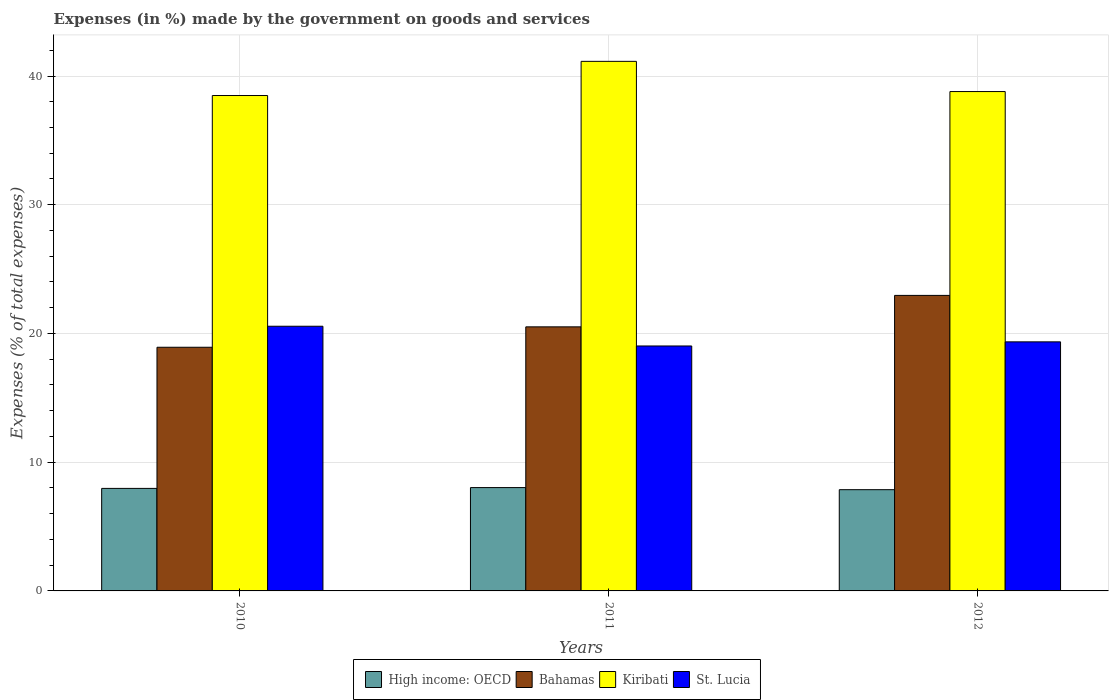How many groups of bars are there?
Provide a short and direct response. 3. Are the number of bars per tick equal to the number of legend labels?
Your answer should be compact. Yes. How many bars are there on the 2nd tick from the right?
Keep it short and to the point. 4. What is the percentage of expenses made by the government on goods and services in St. Lucia in 2010?
Provide a short and direct response. 20.56. Across all years, what is the maximum percentage of expenses made by the government on goods and services in High income: OECD?
Give a very brief answer. 8.03. Across all years, what is the minimum percentage of expenses made by the government on goods and services in High income: OECD?
Offer a very short reply. 7.86. What is the total percentage of expenses made by the government on goods and services in Bahamas in the graph?
Offer a very short reply. 62.4. What is the difference between the percentage of expenses made by the government on goods and services in High income: OECD in 2011 and that in 2012?
Provide a succinct answer. 0.16. What is the difference between the percentage of expenses made by the government on goods and services in High income: OECD in 2011 and the percentage of expenses made by the government on goods and services in St. Lucia in 2010?
Your response must be concise. -12.53. What is the average percentage of expenses made by the government on goods and services in Bahamas per year?
Offer a very short reply. 20.8. In the year 2012, what is the difference between the percentage of expenses made by the government on goods and services in Bahamas and percentage of expenses made by the government on goods and services in Kiribati?
Keep it short and to the point. -15.84. What is the ratio of the percentage of expenses made by the government on goods and services in Bahamas in 2010 to that in 2011?
Your answer should be compact. 0.92. Is the percentage of expenses made by the government on goods and services in Kiribati in 2011 less than that in 2012?
Provide a succinct answer. No. Is the difference between the percentage of expenses made by the government on goods and services in Bahamas in 2010 and 2011 greater than the difference between the percentage of expenses made by the government on goods and services in Kiribati in 2010 and 2011?
Provide a short and direct response. Yes. What is the difference between the highest and the second highest percentage of expenses made by the government on goods and services in Bahamas?
Make the answer very short. 2.44. What is the difference between the highest and the lowest percentage of expenses made by the government on goods and services in Bahamas?
Make the answer very short. 4.03. What does the 1st bar from the left in 2012 represents?
Keep it short and to the point. High income: OECD. What does the 2nd bar from the right in 2011 represents?
Provide a succinct answer. Kiribati. How many bars are there?
Make the answer very short. 12. Are all the bars in the graph horizontal?
Provide a succinct answer. No. How many years are there in the graph?
Give a very brief answer. 3. Are the values on the major ticks of Y-axis written in scientific E-notation?
Your answer should be very brief. No. Does the graph contain any zero values?
Keep it short and to the point. No. Does the graph contain grids?
Ensure brevity in your answer.  Yes. How many legend labels are there?
Your answer should be very brief. 4. What is the title of the graph?
Make the answer very short. Expenses (in %) made by the government on goods and services. What is the label or title of the Y-axis?
Make the answer very short. Expenses (% of total expenses). What is the Expenses (% of total expenses) of High income: OECD in 2010?
Your answer should be very brief. 7.96. What is the Expenses (% of total expenses) of Bahamas in 2010?
Offer a very short reply. 18.93. What is the Expenses (% of total expenses) of Kiribati in 2010?
Provide a short and direct response. 38.49. What is the Expenses (% of total expenses) of St. Lucia in 2010?
Provide a short and direct response. 20.56. What is the Expenses (% of total expenses) in High income: OECD in 2011?
Keep it short and to the point. 8.03. What is the Expenses (% of total expenses) of Bahamas in 2011?
Offer a very short reply. 20.51. What is the Expenses (% of total expenses) in Kiribati in 2011?
Provide a short and direct response. 41.14. What is the Expenses (% of total expenses) of St. Lucia in 2011?
Your answer should be compact. 19.03. What is the Expenses (% of total expenses) of High income: OECD in 2012?
Make the answer very short. 7.86. What is the Expenses (% of total expenses) in Bahamas in 2012?
Your answer should be very brief. 22.96. What is the Expenses (% of total expenses) of Kiribati in 2012?
Offer a very short reply. 38.79. What is the Expenses (% of total expenses) of St. Lucia in 2012?
Ensure brevity in your answer.  19.35. Across all years, what is the maximum Expenses (% of total expenses) of High income: OECD?
Give a very brief answer. 8.03. Across all years, what is the maximum Expenses (% of total expenses) in Bahamas?
Your answer should be very brief. 22.96. Across all years, what is the maximum Expenses (% of total expenses) in Kiribati?
Ensure brevity in your answer.  41.14. Across all years, what is the maximum Expenses (% of total expenses) of St. Lucia?
Offer a terse response. 20.56. Across all years, what is the minimum Expenses (% of total expenses) of High income: OECD?
Give a very brief answer. 7.86. Across all years, what is the minimum Expenses (% of total expenses) in Bahamas?
Offer a very short reply. 18.93. Across all years, what is the minimum Expenses (% of total expenses) in Kiribati?
Provide a short and direct response. 38.49. Across all years, what is the minimum Expenses (% of total expenses) in St. Lucia?
Your answer should be very brief. 19.03. What is the total Expenses (% of total expenses) of High income: OECD in the graph?
Offer a very short reply. 23.86. What is the total Expenses (% of total expenses) of Bahamas in the graph?
Offer a terse response. 62.4. What is the total Expenses (% of total expenses) in Kiribati in the graph?
Keep it short and to the point. 118.42. What is the total Expenses (% of total expenses) of St. Lucia in the graph?
Provide a succinct answer. 58.94. What is the difference between the Expenses (% of total expenses) in High income: OECD in 2010 and that in 2011?
Your response must be concise. -0.06. What is the difference between the Expenses (% of total expenses) of Bahamas in 2010 and that in 2011?
Keep it short and to the point. -1.59. What is the difference between the Expenses (% of total expenses) in Kiribati in 2010 and that in 2011?
Provide a short and direct response. -2.65. What is the difference between the Expenses (% of total expenses) of St. Lucia in 2010 and that in 2011?
Your answer should be very brief. 1.53. What is the difference between the Expenses (% of total expenses) of High income: OECD in 2010 and that in 2012?
Ensure brevity in your answer.  0.1. What is the difference between the Expenses (% of total expenses) of Bahamas in 2010 and that in 2012?
Provide a succinct answer. -4.03. What is the difference between the Expenses (% of total expenses) of Kiribati in 2010 and that in 2012?
Keep it short and to the point. -0.31. What is the difference between the Expenses (% of total expenses) in St. Lucia in 2010 and that in 2012?
Offer a terse response. 1.21. What is the difference between the Expenses (% of total expenses) in High income: OECD in 2011 and that in 2012?
Offer a terse response. 0.16. What is the difference between the Expenses (% of total expenses) of Bahamas in 2011 and that in 2012?
Provide a short and direct response. -2.44. What is the difference between the Expenses (% of total expenses) in Kiribati in 2011 and that in 2012?
Your response must be concise. 2.35. What is the difference between the Expenses (% of total expenses) in St. Lucia in 2011 and that in 2012?
Keep it short and to the point. -0.32. What is the difference between the Expenses (% of total expenses) in High income: OECD in 2010 and the Expenses (% of total expenses) in Bahamas in 2011?
Provide a short and direct response. -12.55. What is the difference between the Expenses (% of total expenses) in High income: OECD in 2010 and the Expenses (% of total expenses) in Kiribati in 2011?
Provide a short and direct response. -33.18. What is the difference between the Expenses (% of total expenses) of High income: OECD in 2010 and the Expenses (% of total expenses) of St. Lucia in 2011?
Keep it short and to the point. -11.06. What is the difference between the Expenses (% of total expenses) in Bahamas in 2010 and the Expenses (% of total expenses) in Kiribati in 2011?
Your response must be concise. -22.21. What is the difference between the Expenses (% of total expenses) of Bahamas in 2010 and the Expenses (% of total expenses) of St. Lucia in 2011?
Offer a terse response. -0.1. What is the difference between the Expenses (% of total expenses) of Kiribati in 2010 and the Expenses (% of total expenses) of St. Lucia in 2011?
Your answer should be compact. 19.46. What is the difference between the Expenses (% of total expenses) in High income: OECD in 2010 and the Expenses (% of total expenses) in Bahamas in 2012?
Your answer should be very brief. -14.99. What is the difference between the Expenses (% of total expenses) of High income: OECD in 2010 and the Expenses (% of total expenses) of Kiribati in 2012?
Provide a short and direct response. -30.83. What is the difference between the Expenses (% of total expenses) of High income: OECD in 2010 and the Expenses (% of total expenses) of St. Lucia in 2012?
Offer a very short reply. -11.38. What is the difference between the Expenses (% of total expenses) of Bahamas in 2010 and the Expenses (% of total expenses) of Kiribati in 2012?
Ensure brevity in your answer.  -19.86. What is the difference between the Expenses (% of total expenses) of Bahamas in 2010 and the Expenses (% of total expenses) of St. Lucia in 2012?
Offer a terse response. -0.42. What is the difference between the Expenses (% of total expenses) in Kiribati in 2010 and the Expenses (% of total expenses) in St. Lucia in 2012?
Keep it short and to the point. 19.14. What is the difference between the Expenses (% of total expenses) in High income: OECD in 2011 and the Expenses (% of total expenses) in Bahamas in 2012?
Make the answer very short. -14.93. What is the difference between the Expenses (% of total expenses) in High income: OECD in 2011 and the Expenses (% of total expenses) in Kiribati in 2012?
Ensure brevity in your answer.  -30.77. What is the difference between the Expenses (% of total expenses) of High income: OECD in 2011 and the Expenses (% of total expenses) of St. Lucia in 2012?
Provide a short and direct response. -11.32. What is the difference between the Expenses (% of total expenses) in Bahamas in 2011 and the Expenses (% of total expenses) in Kiribati in 2012?
Keep it short and to the point. -18.28. What is the difference between the Expenses (% of total expenses) of Bahamas in 2011 and the Expenses (% of total expenses) of St. Lucia in 2012?
Your response must be concise. 1.17. What is the difference between the Expenses (% of total expenses) of Kiribati in 2011 and the Expenses (% of total expenses) of St. Lucia in 2012?
Keep it short and to the point. 21.79. What is the average Expenses (% of total expenses) in High income: OECD per year?
Offer a very short reply. 7.95. What is the average Expenses (% of total expenses) of Bahamas per year?
Keep it short and to the point. 20.8. What is the average Expenses (% of total expenses) of Kiribati per year?
Ensure brevity in your answer.  39.47. What is the average Expenses (% of total expenses) of St. Lucia per year?
Give a very brief answer. 19.65. In the year 2010, what is the difference between the Expenses (% of total expenses) of High income: OECD and Expenses (% of total expenses) of Bahamas?
Make the answer very short. -10.96. In the year 2010, what is the difference between the Expenses (% of total expenses) of High income: OECD and Expenses (% of total expenses) of Kiribati?
Your answer should be compact. -30.52. In the year 2010, what is the difference between the Expenses (% of total expenses) of High income: OECD and Expenses (% of total expenses) of St. Lucia?
Offer a very short reply. -12.6. In the year 2010, what is the difference between the Expenses (% of total expenses) of Bahamas and Expenses (% of total expenses) of Kiribati?
Keep it short and to the point. -19.56. In the year 2010, what is the difference between the Expenses (% of total expenses) in Bahamas and Expenses (% of total expenses) in St. Lucia?
Offer a terse response. -1.63. In the year 2010, what is the difference between the Expenses (% of total expenses) of Kiribati and Expenses (% of total expenses) of St. Lucia?
Offer a terse response. 17.92. In the year 2011, what is the difference between the Expenses (% of total expenses) of High income: OECD and Expenses (% of total expenses) of Bahamas?
Give a very brief answer. -12.49. In the year 2011, what is the difference between the Expenses (% of total expenses) of High income: OECD and Expenses (% of total expenses) of Kiribati?
Provide a short and direct response. -33.11. In the year 2011, what is the difference between the Expenses (% of total expenses) of High income: OECD and Expenses (% of total expenses) of St. Lucia?
Keep it short and to the point. -11. In the year 2011, what is the difference between the Expenses (% of total expenses) of Bahamas and Expenses (% of total expenses) of Kiribati?
Give a very brief answer. -20.62. In the year 2011, what is the difference between the Expenses (% of total expenses) in Bahamas and Expenses (% of total expenses) in St. Lucia?
Offer a terse response. 1.49. In the year 2011, what is the difference between the Expenses (% of total expenses) in Kiribati and Expenses (% of total expenses) in St. Lucia?
Offer a very short reply. 22.11. In the year 2012, what is the difference between the Expenses (% of total expenses) in High income: OECD and Expenses (% of total expenses) in Bahamas?
Make the answer very short. -15.09. In the year 2012, what is the difference between the Expenses (% of total expenses) of High income: OECD and Expenses (% of total expenses) of Kiribati?
Offer a very short reply. -30.93. In the year 2012, what is the difference between the Expenses (% of total expenses) in High income: OECD and Expenses (% of total expenses) in St. Lucia?
Keep it short and to the point. -11.48. In the year 2012, what is the difference between the Expenses (% of total expenses) in Bahamas and Expenses (% of total expenses) in Kiribati?
Your answer should be very brief. -15.84. In the year 2012, what is the difference between the Expenses (% of total expenses) in Bahamas and Expenses (% of total expenses) in St. Lucia?
Your answer should be very brief. 3.61. In the year 2012, what is the difference between the Expenses (% of total expenses) in Kiribati and Expenses (% of total expenses) in St. Lucia?
Your answer should be very brief. 19.44. What is the ratio of the Expenses (% of total expenses) in High income: OECD in 2010 to that in 2011?
Give a very brief answer. 0.99. What is the ratio of the Expenses (% of total expenses) in Bahamas in 2010 to that in 2011?
Your answer should be compact. 0.92. What is the ratio of the Expenses (% of total expenses) in Kiribati in 2010 to that in 2011?
Offer a terse response. 0.94. What is the ratio of the Expenses (% of total expenses) of St. Lucia in 2010 to that in 2011?
Offer a very short reply. 1.08. What is the ratio of the Expenses (% of total expenses) in High income: OECD in 2010 to that in 2012?
Make the answer very short. 1.01. What is the ratio of the Expenses (% of total expenses) in Bahamas in 2010 to that in 2012?
Make the answer very short. 0.82. What is the ratio of the Expenses (% of total expenses) of Kiribati in 2010 to that in 2012?
Make the answer very short. 0.99. What is the ratio of the Expenses (% of total expenses) in St. Lucia in 2010 to that in 2012?
Your answer should be compact. 1.06. What is the ratio of the Expenses (% of total expenses) in High income: OECD in 2011 to that in 2012?
Offer a terse response. 1.02. What is the ratio of the Expenses (% of total expenses) of Bahamas in 2011 to that in 2012?
Keep it short and to the point. 0.89. What is the ratio of the Expenses (% of total expenses) of Kiribati in 2011 to that in 2012?
Provide a short and direct response. 1.06. What is the ratio of the Expenses (% of total expenses) in St. Lucia in 2011 to that in 2012?
Provide a succinct answer. 0.98. What is the difference between the highest and the second highest Expenses (% of total expenses) in High income: OECD?
Your answer should be very brief. 0.06. What is the difference between the highest and the second highest Expenses (% of total expenses) of Bahamas?
Keep it short and to the point. 2.44. What is the difference between the highest and the second highest Expenses (% of total expenses) of Kiribati?
Provide a succinct answer. 2.35. What is the difference between the highest and the second highest Expenses (% of total expenses) in St. Lucia?
Give a very brief answer. 1.21. What is the difference between the highest and the lowest Expenses (% of total expenses) of High income: OECD?
Make the answer very short. 0.16. What is the difference between the highest and the lowest Expenses (% of total expenses) in Bahamas?
Make the answer very short. 4.03. What is the difference between the highest and the lowest Expenses (% of total expenses) in Kiribati?
Your response must be concise. 2.65. What is the difference between the highest and the lowest Expenses (% of total expenses) of St. Lucia?
Offer a very short reply. 1.53. 